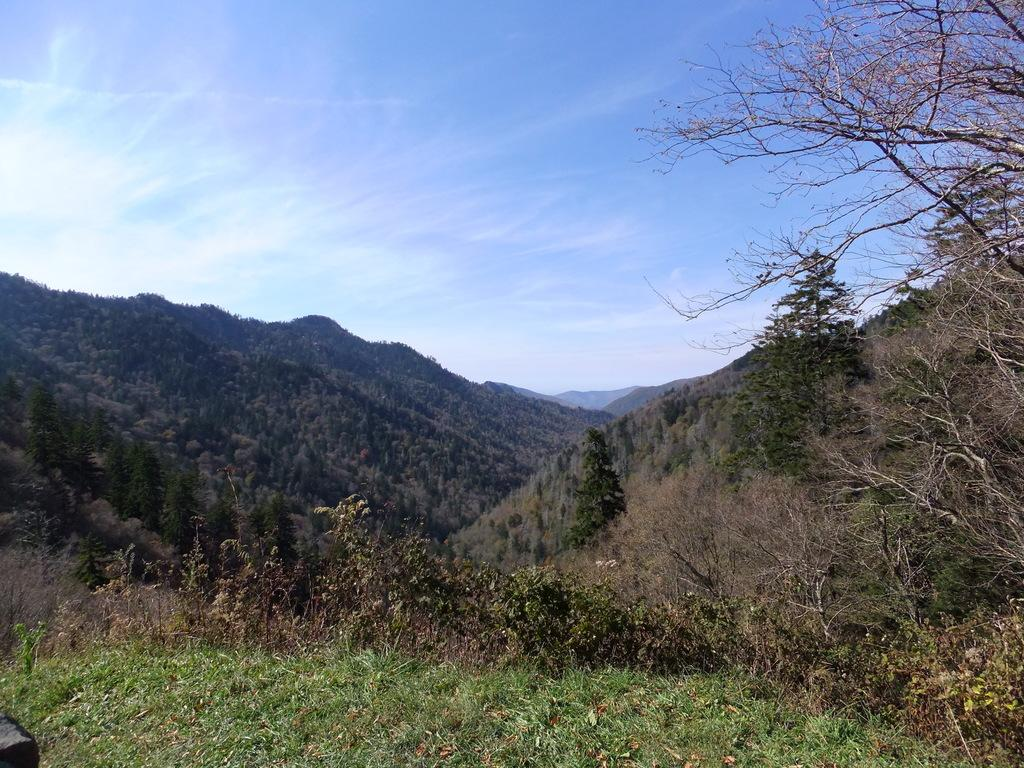What type of natural formation can be seen in the image? There are mountains in the image. What is located in front of the mountains? There is grass and trees in front of the mountains. What is visible above the mountains? The sky is visible above the mountains. What can be seen in the sky? Clouds are present in the sky. What month is it in the image? The month cannot be determined from the image, as it does not contain any information about the time of year. 